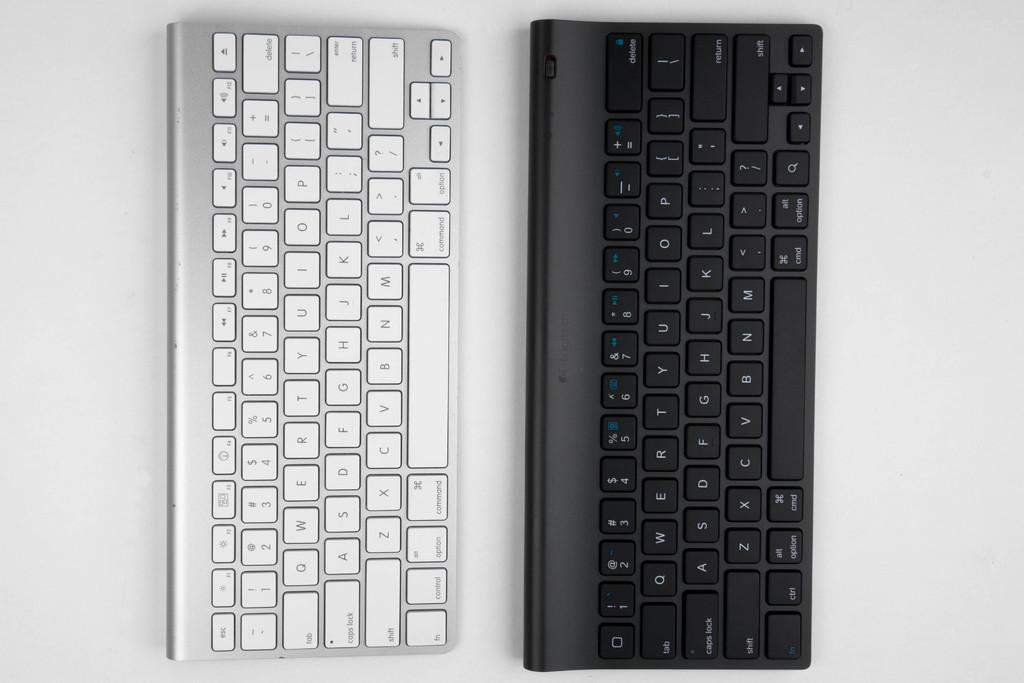<image>
Share a concise interpretation of the image provided. A silver keyboard and black keyboard both have command keys on them. 